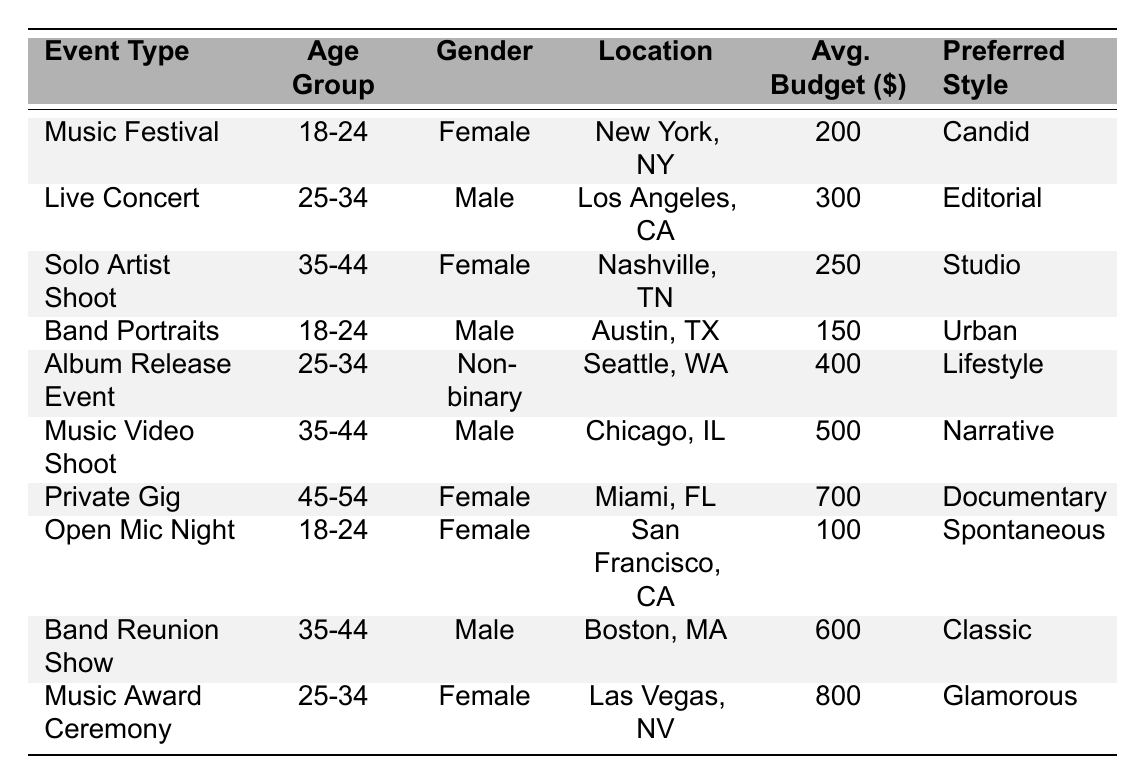What is the average budget for a Music Festival event? The average budget for a Music Festival, as shown in the table, is listed as $200.
Answer: 200 Which gender has the highest average budget for their events? The highest average budget is $800 for the Music Award Ceremony, which is attended by a Female, indicating that Female clients have the highest average budget when considering this specific event.
Answer: Female How many events are listed for the 18-24 age group? By counting the rows in the table corresponding to the age group 18-24, we find there are 3 events: Music Festival, Band Portraits, and Open Mic Night.
Answer: 3 What is the preferred style for clients located in Los Angeles, CA? The event in Los Angeles, CA is a Live Concert, and the preferred style mentioned for this event is Editorial.
Answer: Editorial Is there an event type where the average budget is above $600? Yes, the events Private Gig and Band Reunion Show have average budgets of $700 and $600 respectively, so there is an event (Private Gig) that surpasses $600.
Answer: Yes What is the median average budget for the events in the table? The average budgets listed are 200, 300, 250, 150, 400, 500, 700, 100, 600, and 800. When sorted in order, we get 100, 150, 200, 250, 300, 400, 500, 600, 700, 800. The median (middle value) for 10 data points is the average of the 5th and 6th values (300 and 400), which is (300 + 400) / 2 = 350.
Answer: 350 For the 35-44 age group, how many different event types are there? The events for the 35-44 age group are Solo Artist Shoot, Music Video Shoot, and Band Reunion Show. Therefore, there are a total of 3 different event types for this age group.
Answer: 3 What is the average budget for Male clients across all events? The budgets for Male clients are $300 (Live Concert), $150 (Band Portraits), $500 (Music Video Shoot), and $600 (Band Reunion Show). The average is calculated as (300 + 150 + 500 + 600) / 4 = 387.5.
Answer: 387.5 Are there more events targeted towards individuals aged 25-34 or those aged 35-44? There are 3 events for the 25-34 age group (Live Concert, Album Release Event, Music Award Ceremony) and 3 events for the 35-44 age group (Solo Artist Shoot, Music Video Shoot, Band Reunion Show), therefore the counts are equal.
Answer: Equal What is the preferred style with the highest average budget? Examining the budgets and corresponding style, the Music Award Ceremony (Glamorous) has the highest average budget of $800, so the preferred style with the highest budget is Glamorous.
Answer: Glamorous Which location has the highest average budget for events? The highest average budget of $800 is assigned to the event in Las Vegas, NV for the Music Award Ceremony. Therefore, Las Vegas, NV has the highest average budget.
Answer: Las Vegas, NV 